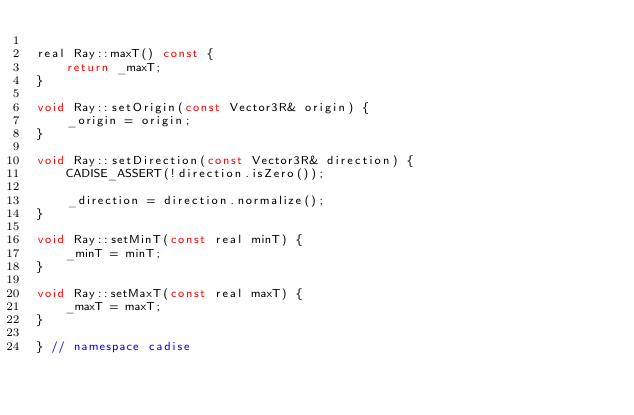Convert code to text. <code><loc_0><loc_0><loc_500><loc_500><_C++_>
real Ray::maxT() const {
    return _maxT;
}

void Ray::setOrigin(const Vector3R& origin) {
    _origin = origin;
}

void Ray::setDirection(const Vector3R& direction) {
    CADISE_ASSERT(!direction.isZero());

    _direction = direction.normalize();
}

void Ray::setMinT(const real minT) {
    _minT = minT;
}

void Ray::setMaxT(const real maxT) {
    _maxT = maxT;
}

} // namespace cadise</code> 